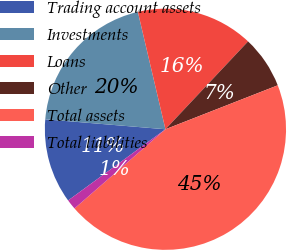Convert chart to OTSL. <chart><loc_0><loc_0><loc_500><loc_500><pie_chart><fcel>Trading account assets<fcel>Investments<fcel>Loans<fcel>Other<fcel>Total assets<fcel>Total liabilities<nl><fcel>11.37%<fcel>20.01%<fcel>15.69%<fcel>7.05%<fcel>44.54%<fcel>1.35%<nl></chart> 